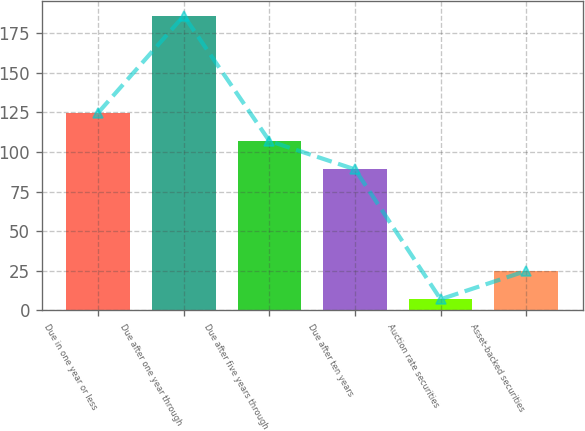Convert chart. <chart><loc_0><loc_0><loc_500><loc_500><bar_chart><fcel>Due in one year or less<fcel>Due after one year through<fcel>Due after five years through<fcel>Due after ten years<fcel>Auction rate securities<fcel>Asset-backed securities<nl><fcel>124.8<fcel>186<fcel>106.9<fcel>89<fcel>7<fcel>24.9<nl></chart> 